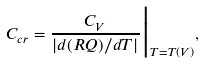<formula> <loc_0><loc_0><loc_500><loc_500>C _ { c r } = \frac { C _ { V } } { | d ( R Q ) / d T | } \Big | _ { T = T ( V ) } ,</formula> 